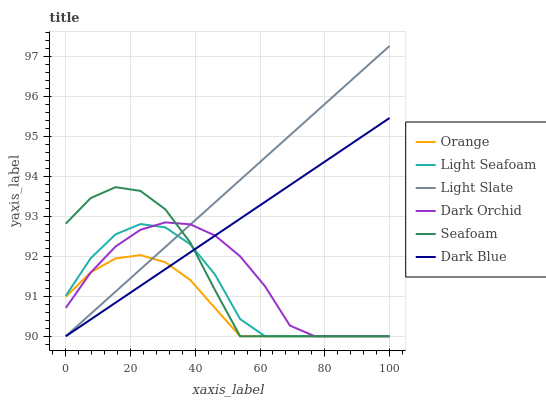Does Orange have the minimum area under the curve?
Answer yes or no. Yes. Does Light Slate have the maximum area under the curve?
Answer yes or no. Yes. Does Seafoam have the minimum area under the curve?
Answer yes or no. No. Does Seafoam have the maximum area under the curve?
Answer yes or no. No. Is Dark Blue the smoothest?
Answer yes or no. Yes. Is Light Seafoam the roughest?
Answer yes or no. Yes. Is Seafoam the smoothest?
Answer yes or no. No. Is Seafoam the roughest?
Answer yes or no. No. Does Light Slate have the lowest value?
Answer yes or no. Yes. Does Light Slate have the highest value?
Answer yes or no. Yes. Does Seafoam have the highest value?
Answer yes or no. No. Does Seafoam intersect Dark Orchid?
Answer yes or no. Yes. Is Seafoam less than Dark Orchid?
Answer yes or no. No. Is Seafoam greater than Dark Orchid?
Answer yes or no. No. 